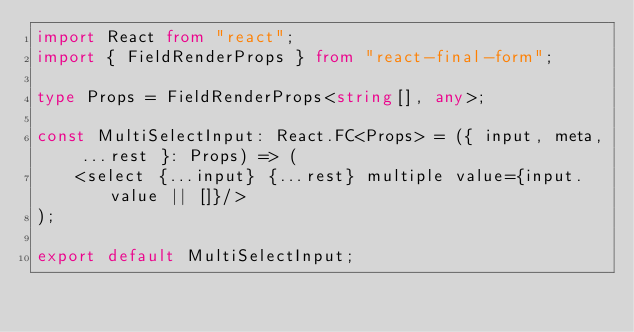Convert code to text. <code><loc_0><loc_0><loc_500><loc_500><_TypeScript_>import React from "react";
import { FieldRenderProps } from "react-final-form";

type Props = FieldRenderProps<string[], any>;

const MultiSelectInput: React.FC<Props> = ({ input, meta, ...rest }: Props) => (
    <select {...input} {...rest} multiple value={input.value || []}/>
);

export default MultiSelectInput;
</code> 